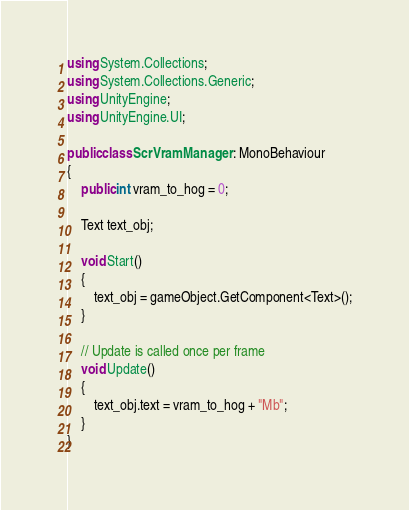<code> <loc_0><loc_0><loc_500><loc_500><_C#_>using System.Collections;
using System.Collections.Generic;
using UnityEngine;
using UnityEngine.UI;

public class ScrVramManager : MonoBehaviour
{
    public int vram_to_hog = 0;

    Text text_obj;

    void Start()
    {
        text_obj = gameObject.GetComponent<Text>();
    }

    // Update is called once per frame
    void Update()
    {
        text_obj.text = vram_to_hog + "Mb";
    }
}
</code> 